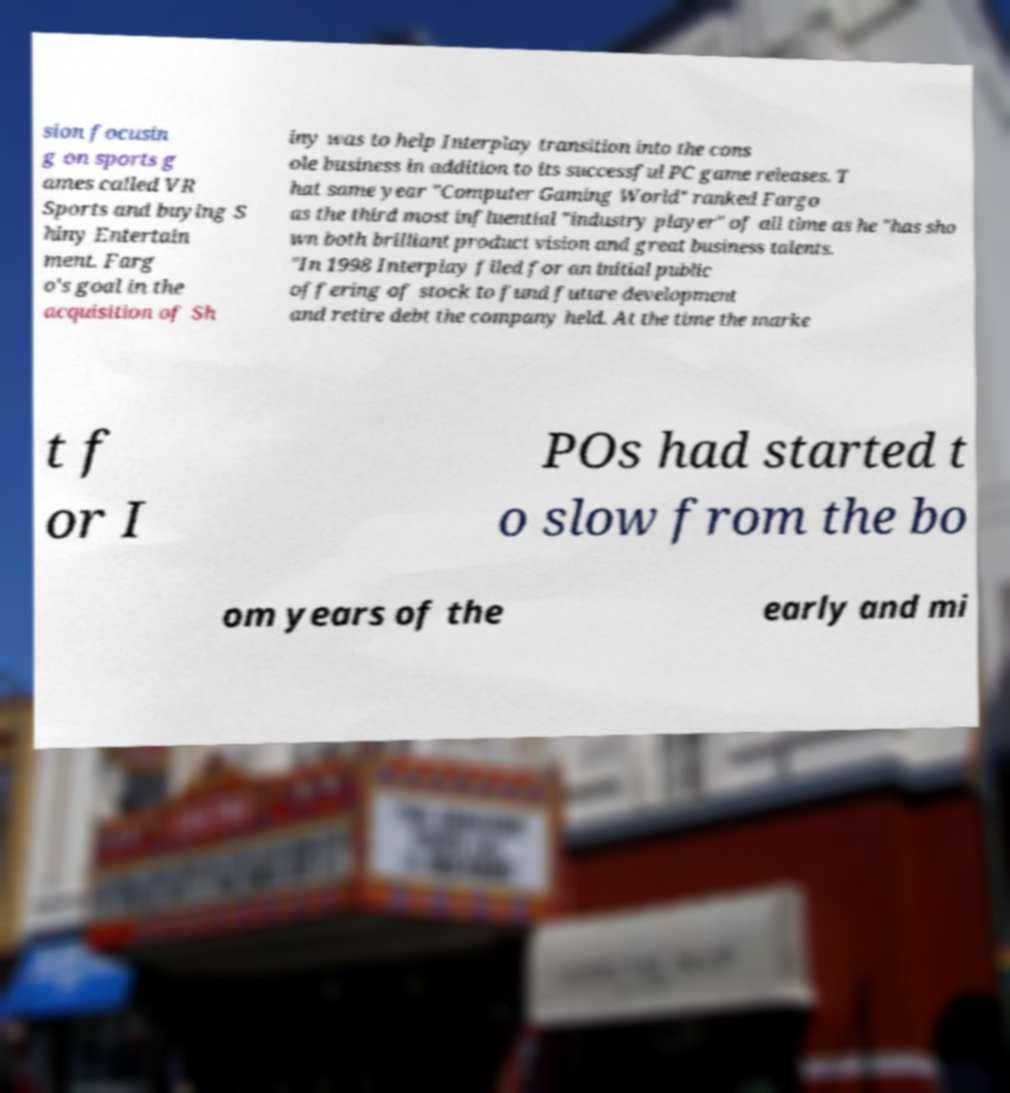Please read and relay the text visible in this image. What does it say? sion focusin g on sports g ames called VR Sports and buying S hiny Entertain ment. Farg o's goal in the acquisition of Sh iny was to help Interplay transition into the cons ole business in addition to its successful PC game releases. T hat same year "Computer Gaming World" ranked Fargo as the third most influential "industry player" of all time as he "has sho wn both brilliant product vision and great business talents. "In 1998 Interplay filed for an initial public offering of stock to fund future development and retire debt the company held. At the time the marke t f or I POs had started t o slow from the bo om years of the early and mi 